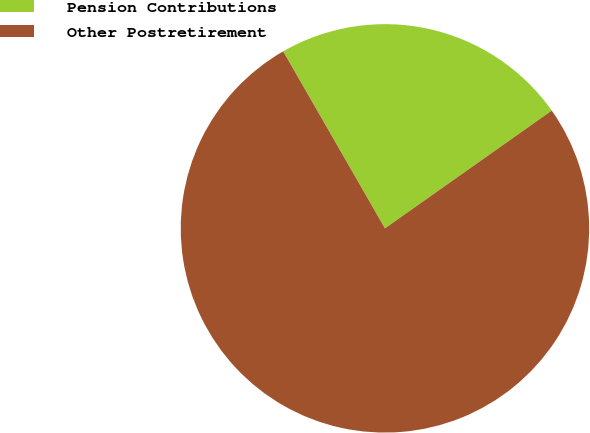Convert chart to OTSL. <chart><loc_0><loc_0><loc_500><loc_500><pie_chart><fcel>Pension Contributions<fcel>Other Postretirement<nl><fcel>23.52%<fcel>76.48%<nl></chart> 